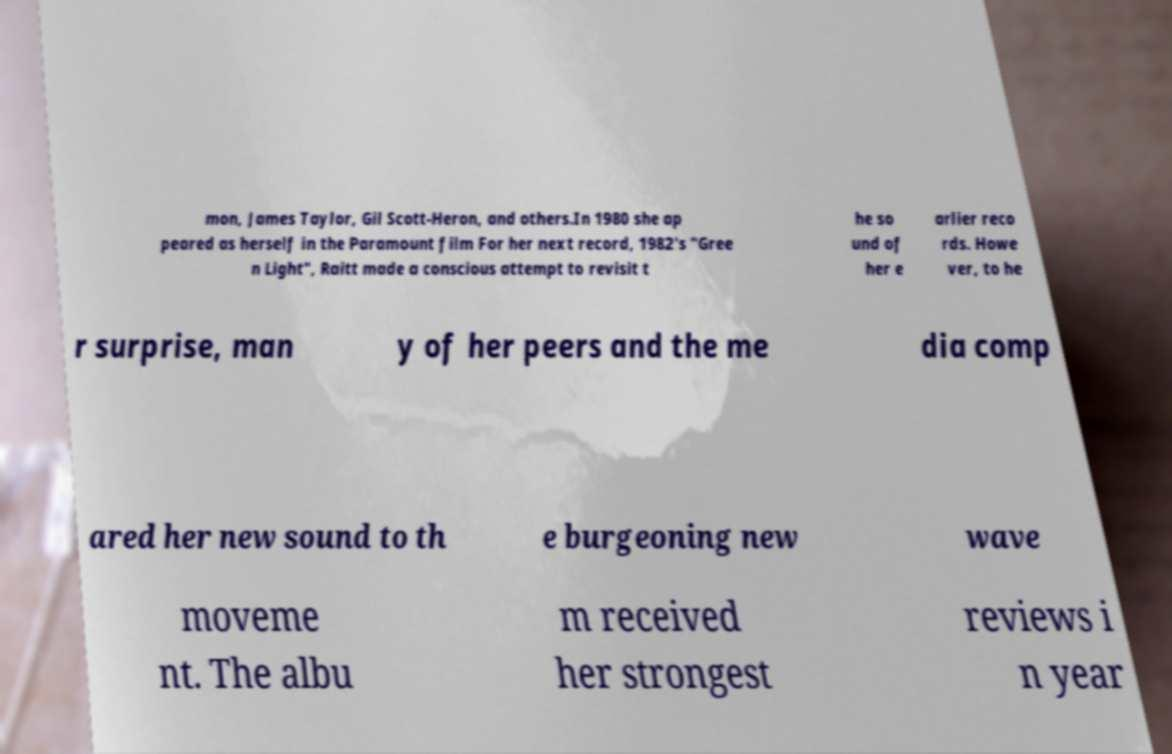There's text embedded in this image that I need extracted. Can you transcribe it verbatim? mon, James Taylor, Gil Scott-Heron, and others.In 1980 she ap peared as herself in the Paramount film For her next record, 1982's "Gree n Light", Raitt made a conscious attempt to revisit t he so und of her e arlier reco rds. Howe ver, to he r surprise, man y of her peers and the me dia comp ared her new sound to th e burgeoning new wave moveme nt. The albu m received her strongest reviews i n year 